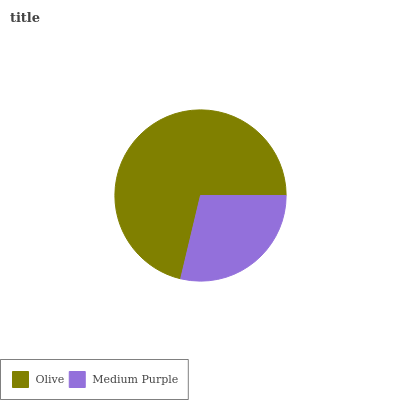Is Medium Purple the minimum?
Answer yes or no. Yes. Is Olive the maximum?
Answer yes or no. Yes. Is Medium Purple the maximum?
Answer yes or no. No. Is Olive greater than Medium Purple?
Answer yes or no. Yes. Is Medium Purple less than Olive?
Answer yes or no. Yes. Is Medium Purple greater than Olive?
Answer yes or no. No. Is Olive less than Medium Purple?
Answer yes or no. No. Is Olive the high median?
Answer yes or no. Yes. Is Medium Purple the low median?
Answer yes or no. Yes. Is Medium Purple the high median?
Answer yes or no. No. Is Olive the low median?
Answer yes or no. No. 